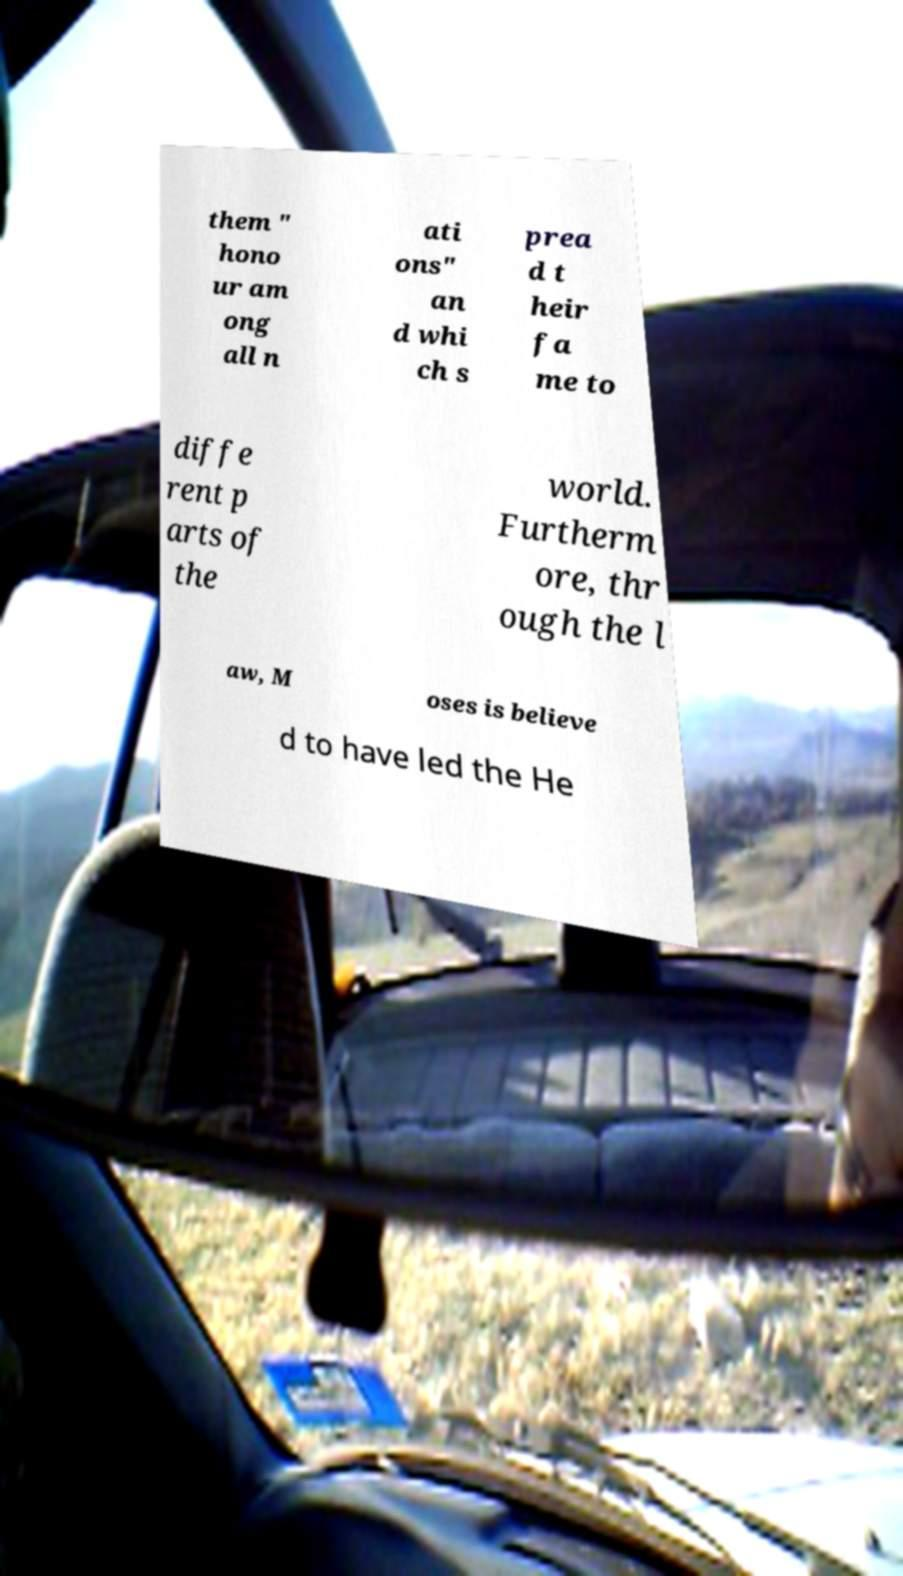For documentation purposes, I need the text within this image transcribed. Could you provide that? them " hono ur am ong all n ati ons" an d whi ch s prea d t heir fa me to diffe rent p arts of the world. Furtherm ore, thr ough the l aw, M oses is believe d to have led the He 